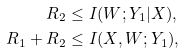<formula> <loc_0><loc_0><loc_500><loc_500>R _ { 2 } & \leq I ( W ; Y _ { 1 } | X ) , \\ R _ { 1 } + R _ { 2 } & \leq I ( X , W ; Y _ { 1 } ) ,</formula> 